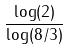Convert formula to latex. <formula><loc_0><loc_0><loc_500><loc_500>\frac { \log ( 2 ) } { \log ( 8 / 3 ) }</formula> 